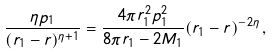<formula> <loc_0><loc_0><loc_500><loc_500>\frac { \eta p _ { 1 } } { ( r _ { 1 } - r ) ^ { \eta + 1 } } = \frac { 4 \pi r _ { 1 } ^ { 2 } p _ { 1 } ^ { 2 } } { 8 \pi r _ { 1 } - 2 M _ { 1 } } ( r _ { 1 } - r ) ^ { - 2 \eta } \, ,</formula> 